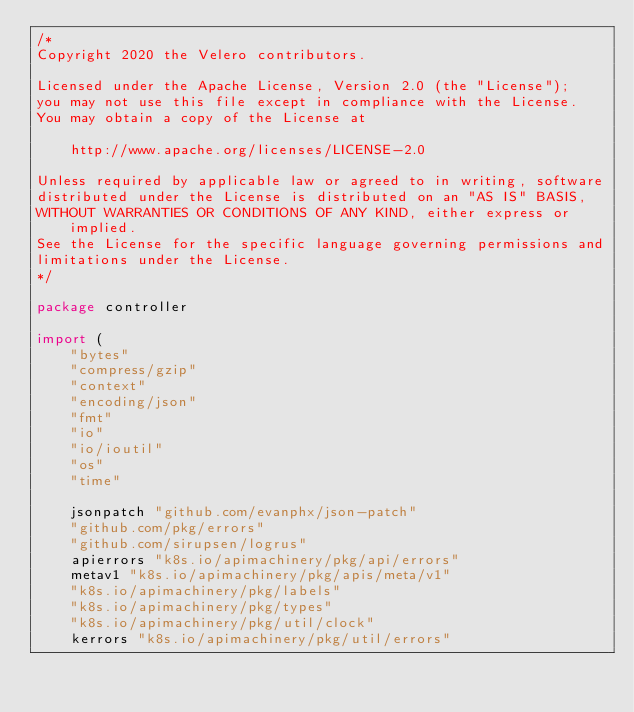Convert code to text. <code><loc_0><loc_0><loc_500><loc_500><_Go_>/*
Copyright 2020 the Velero contributors.

Licensed under the Apache License, Version 2.0 (the "License");
you may not use this file except in compliance with the License.
You may obtain a copy of the License at

    http://www.apache.org/licenses/LICENSE-2.0

Unless required by applicable law or agreed to in writing, software
distributed under the License is distributed on an "AS IS" BASIS,
WITHOUT WARRANTIES OR CONDITIONS OF ANY KIND, either express or implied.
See the License for the specific language governing permissions and
limitations under the License.
*/

package controller

import (
	"bytes"
	"compress/gzip"
	"context"
	"encoding/json"
	"fmt"
	"io"
	"io/ioutil"
	"os"
	"time"

	jsonpatch "github.com/evanphx/json-patch"
	"github.com/pkg/errors"
	"github.com/sirupsen/logrus"
	apierrors "k8s.io/apimachinery/pkg/api/errors"
	metav1 "k8s.io/apimachinery/pkg/apis/meta/v1"
	"k8s.io/apimachinery/pkg/labels"
	"k8s.io/apimachinery/pkg/types"
	"k8s.io/apimachinery/pkg/util/clock"
	kerrors "k8s.io/apimachinery/pkg/util/errors"</code> 